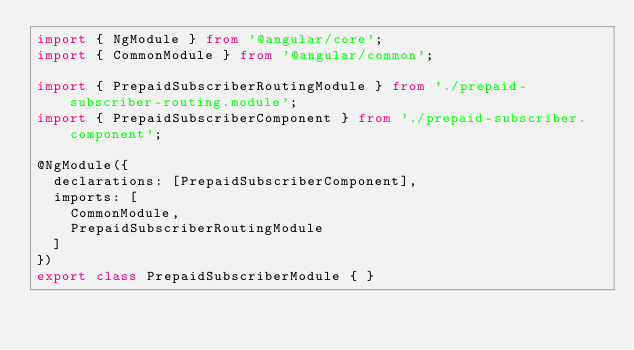<code> <loc_0><loc_0><loc_500><loc_500><_TypeScript_>import { NgModule } from '@angular/core';
import { CommonModule } from '@angular/common';

import { PrepaidSubscriberRoutingModule } from './prepaid-subscriber-routing.module';
import { PrepaidSubscriberComponent } from './prepaid-subscriber.component';

@NgModule({
  declarations: [PrepaidSubscriberComponent],
  imports: [
    CommonModule,
    PrepaidSubscriberRoutingModule
  ]
})
export class PrepaidSubscriberModule { }
</code> 